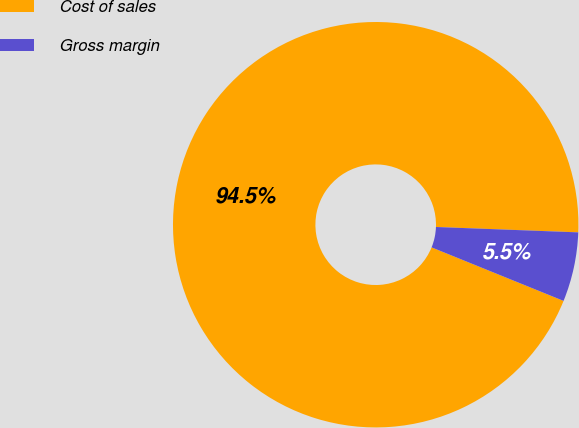Convert chart. <chart><loc_0><loc_0><loc_500><loc_500><pie_chart><fcel>Cost of sales<fcel>Gross margin<nl><fcel>94.47%<fcel>5.53%<nl></chart> 